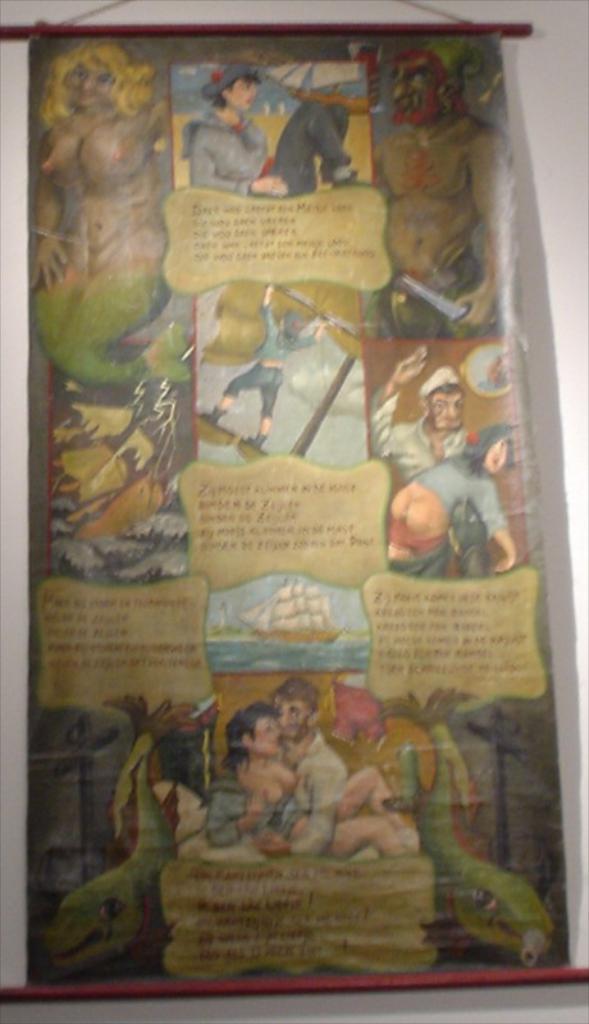Describe this image in one or two sentences. In the image there is a poster and there are different images and description of the images mentioned in the poster. 